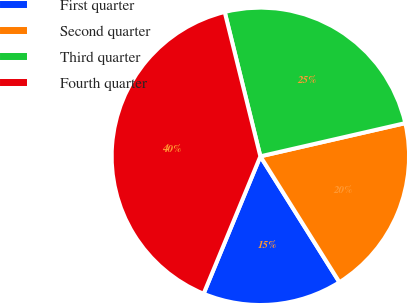<chart> <loc_0><loc_0><loc_500><loc_500><pie_chart><fcel>First quarter<fcel>Second quarter<fcel>Third quarter<fcel>Fourth quarter<nl><fcel>15.16%<fcel>19.66%<fcel>25.27%<fcel>39.91%<nl></chart> 